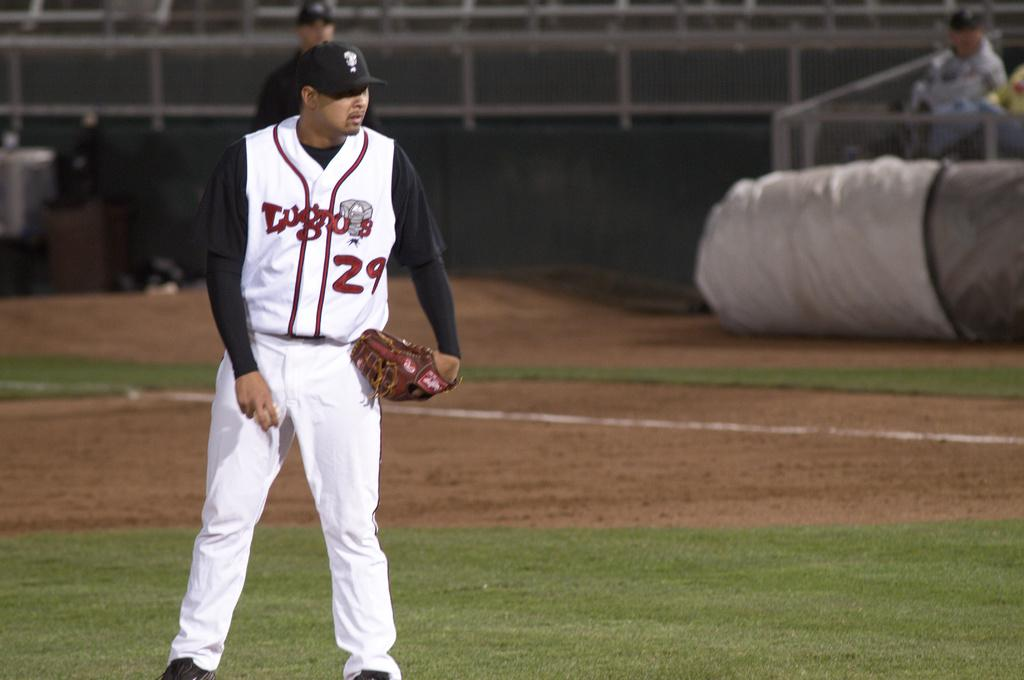Provide a one-sentence caption for the provided image. a player of baseball that is wearing the number 29. 